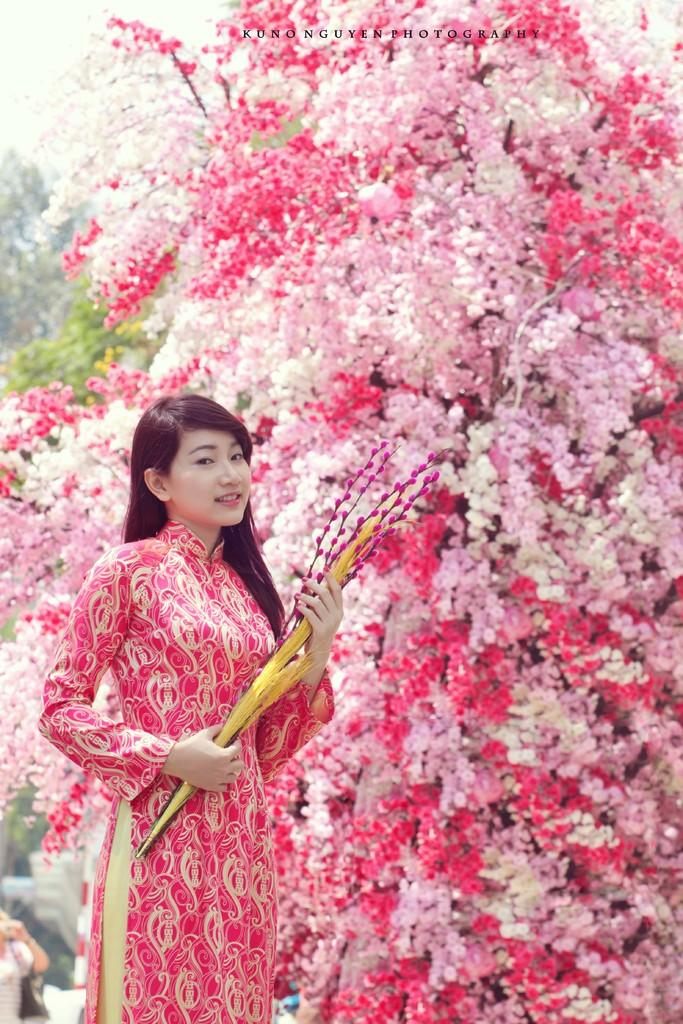What type of vegetation can be seen in the image? There are trees in the image. What other natural elements can be seen in the image? There are flowers in the image. What is visible in the background of the image? The sky is visible in the image. Who is present in the image? There is a woman standing in the front of the image. What is the profit of the woman in the image? There is no information about the woman's profit in the image. What is the opinion of the trees in the image? There is no indication of the trees having an opinion in the image. 